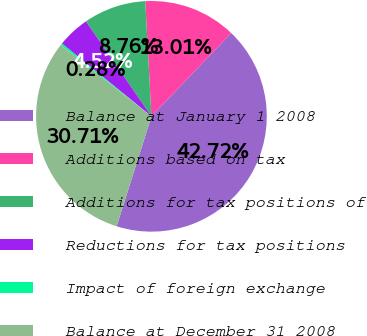Convert chart to OTSL. <chart><loc_0><loc_0><loc_500><loc_500><pie_chart><fcel>Balance at January 1 2008<fcel>Additions based on tax<fcel>Additions for tax positions of<fcel>Reductions for tax positions<fcel>Impact of foreign exchange<fcel>Balance at December 31 2008<nl><fcel>42.72%<fcel>13.01%<fcel>8.76%<fcel>4.52%<fcel>0.28%<fcel>30.71%<nl></chart> 